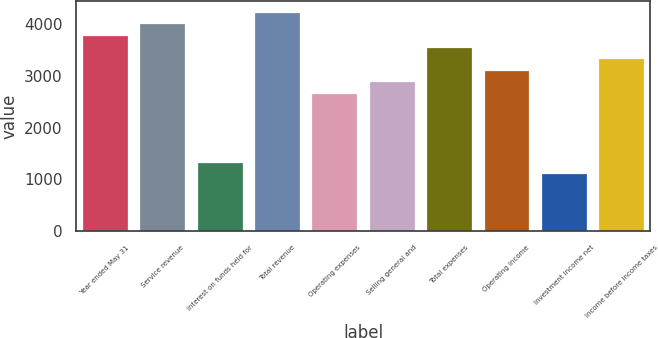Convert chart. <chart><loc_0><loc_0><loc_500><loc_500><bar_chart><fcel>Year ended May 31<fcel>Service revenue<fcel>Interest on funds held for<fcel>Total revenue<fcel>Operating expenses<fcel>Selling general and<fcel>Total expenses<fcel>Operating income<fcel>Investment income net<fcel>Income before income taxes<nl><fcel>3790.52<fcel>4013.48<fcel>1337.96<fcel>4236.44<fcel>2675.72<fcel>2898.68<fcel>3567.56<fcel>3121.64<fcel>1115<fcel>3344.6<nl></chart> 